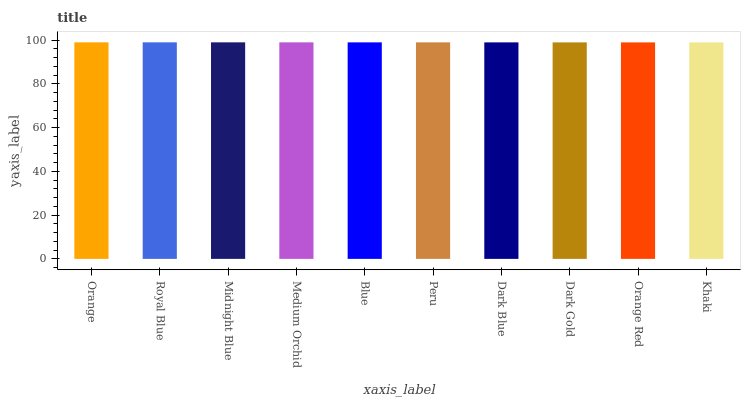Is Khaki the minimum?
Answer yes or no. Yes. Is Orange the maximum?
Answer yes or no. Yes. Is Royal Blue the minimum?
Answer yes or no. No. Is Royal Blue the maximum?
Answer yes or no. No. Is Orange greater than Royal Blue?
Answer yes or no. Yes. Is Royal Blue less than Orange?
Answer yes or no. Yes. Is Royal Blue greater than Orange?
Answer yes or no. No. Is Orange less than Royal Blue?
Answer yes or no. No. Is Blue the high median?
Answer yes or no. Yes. Is Peru the low median?
Answer yes or no. Yes. Is Midnight Blue the high median?
Answer yes or no. No. Is Orange the low median?
Answer yes or no. No. 